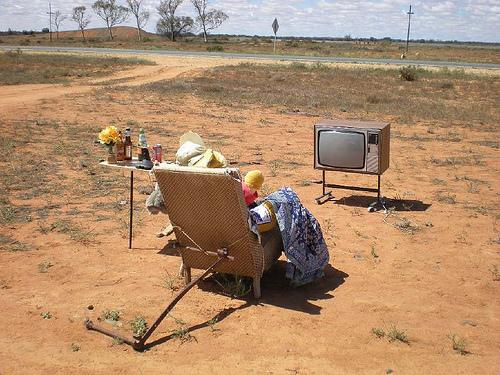Why can't they watch the television?

Choices:
A) no electricity
B) old television
C) broken television
D) solar glare no electricity 